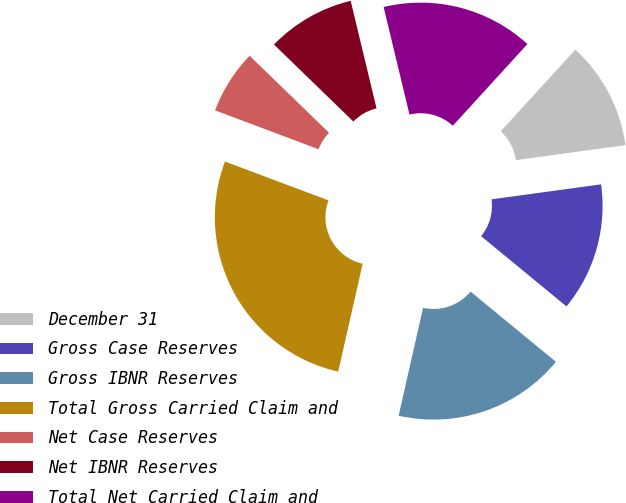Convert chart to OTSL. <chart><loc_0><loc_0><loc_500><loc_500><pie_chart><fcel>December 31<fcel>Gross Case Reserves<fcel>Gross IBNR Reserves<fcel>Total Gross Carried Claim and<fcel>Net Case Reserves<fcel>Net IBNR Reserves<fcel>Total Net Carried Claim and<nl><fcel>11.06%<fcel>13.12%<fcel>17.59%<fcel>27.17%<fcel>6.54%<fcel>8.99%<fcel>15.53%<nl></chart> 